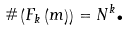<formula> <loc_0><loc_0><loc_500><loc_500>\# \left ( F _ { k } \left ( m \right ) \right ) = N ^ { k } \text {.}</formula> 